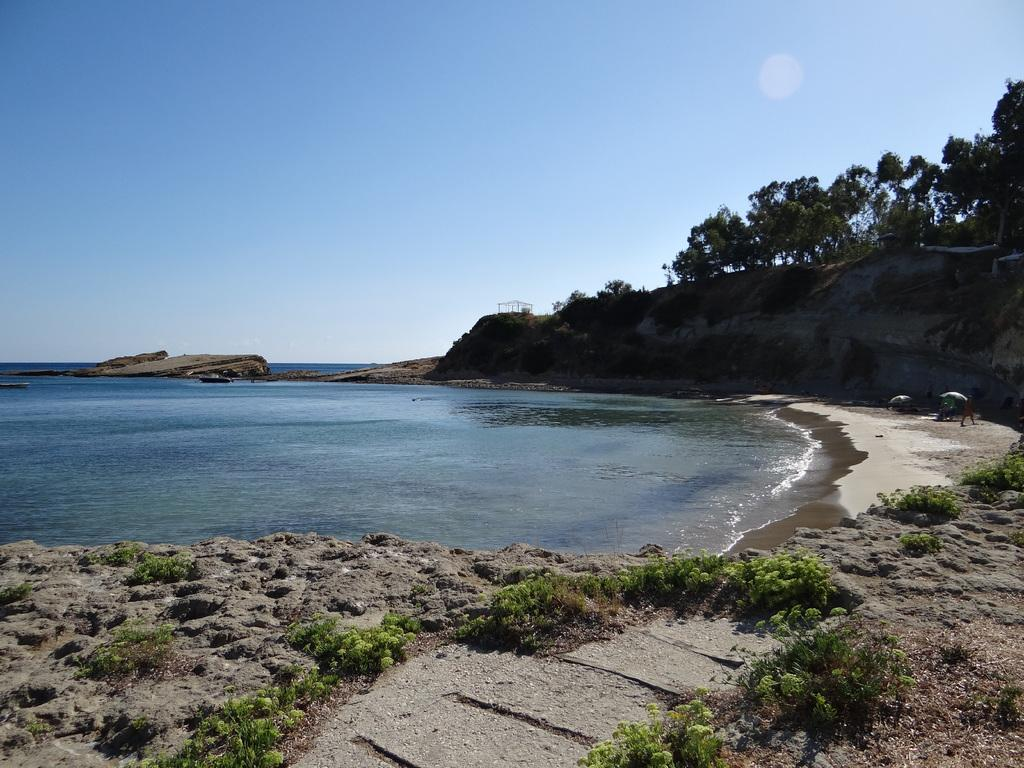What type of vegetation can be seen on dry land in the image? There are plants on dry land in the image. What body of water is visible in the background? There is an ocean in the background. What other natural features can be seen in the background? There are trees on a hill in the background. What is the color of the sky in the image? The sky is blue in the image. What celestial body is visible in the sky? The sun is visible in the sky. How does the society function in the image? There is no reference to a society in the image, so it is not possible to answer that question. Can you describe the bee's role in the image? There are no bees present in the image. 